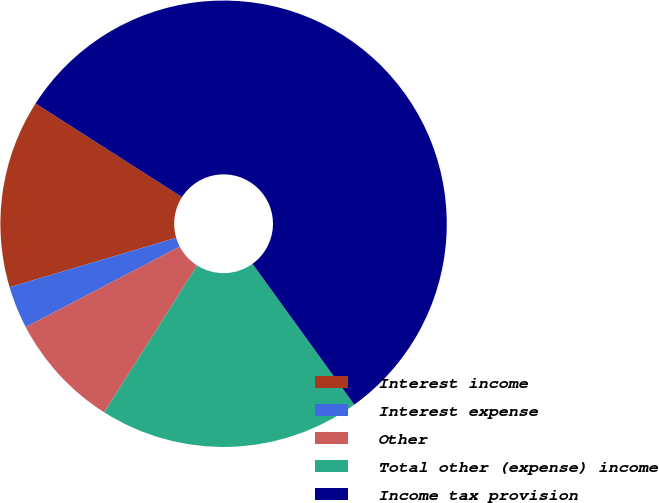Convert chart. <chart><loc_0><loc_0><loc_500><loc_500><pie_chart><fcel>Interest income<fcel>Interest expense<fcel>Other<fcel>Total other (expense) income<fcel>Income tax provision<nl><fcel>13.65%<fcel>3.07%<fcel>8.36%<fcel>18.94%<fcel>55.98%<nl></chart> 